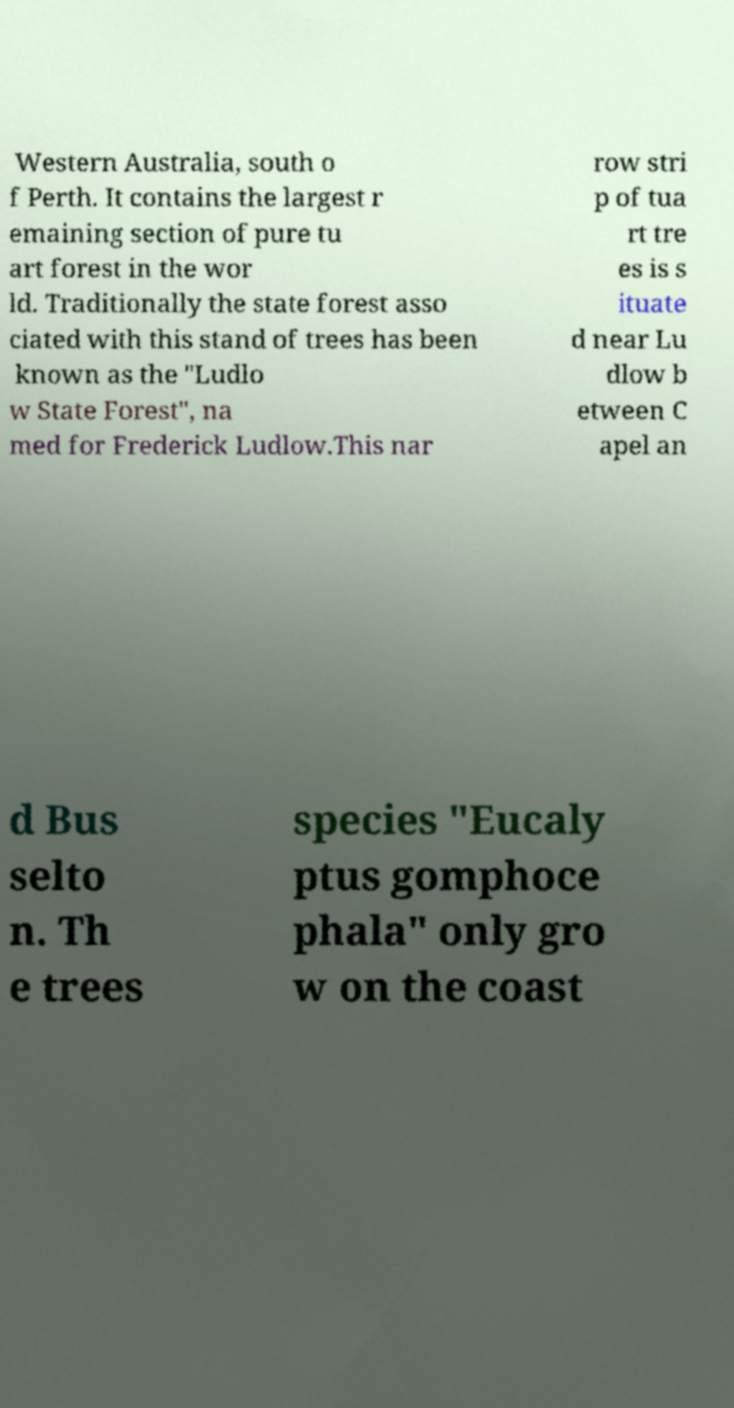For documentation purposes, I need the text within this image transcribed. Could you provide that? Western Australia, south o f Perth. It contains the largest r emaining section of pure tu art forest in the wor ld. Traditionally the state forest asso ciated with this stand of trees has been known as the "Ludlo w State Forest", na med for Frederick Ludlow.This nar row stri p of tua rt tre es is s ituate d near Lu dlow b etween C apel an d Bus selto n. Th e trees species "Eucaly ptus gomphoce phala" only gro w on the coast 